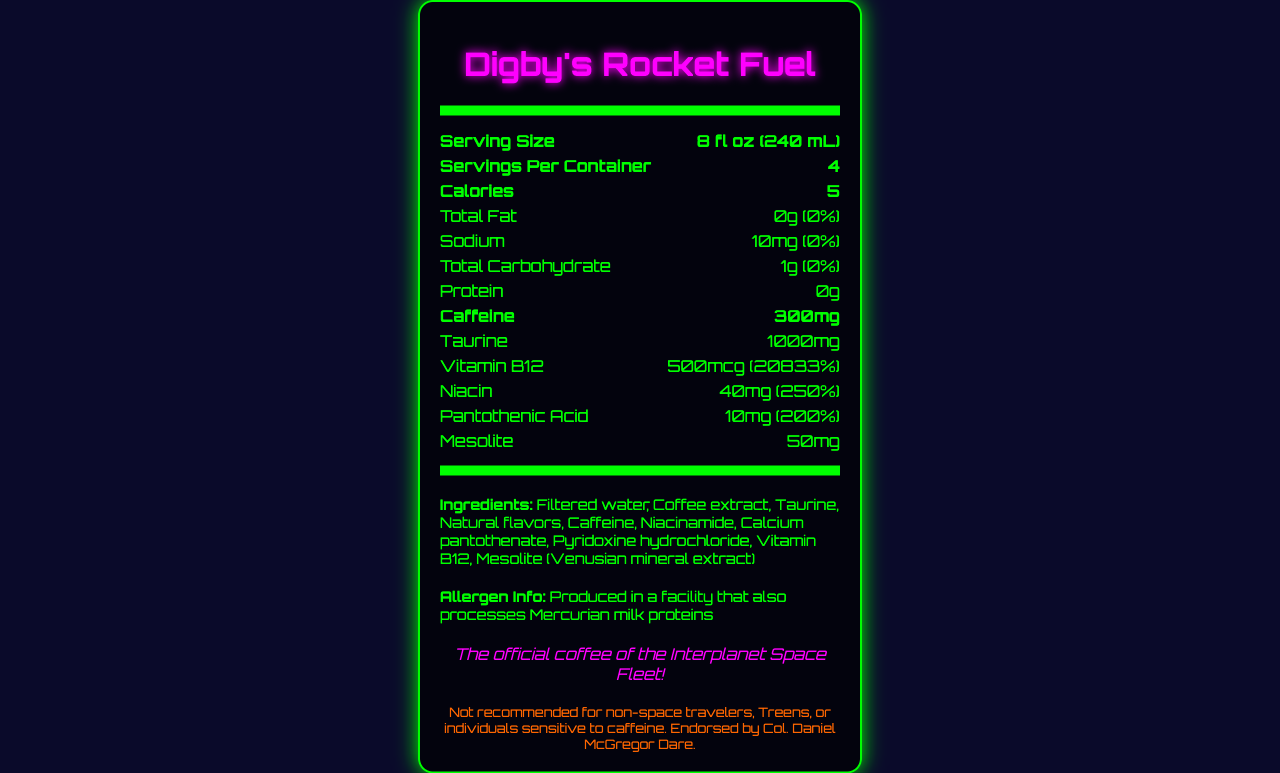what is the serving size? The serving size is listed in the document as 8 fl oz (240 mL).
Answer: 8 fl oz (240 mL) how many calories are in one serving? The document shows that one serving contains 5 calories.
Answer: 5 calories what does the document list as the amount of caffeine per serving? The amount of caffeine per serving is indicated as 300mg in the document.
Answer: 300mg how much Vitamin B12 is there per serving? The document states that each serving contains 500mcg of Vitamin B12, providing 20833% of the daily value.
Answer: 500mcg (20833% Daily Value) who is the manufacturer of Digby's Rocket Fuel? The manufacturer's name listed in the document is Spacefleet Provisions Ltd.
Answer: Spacefleet Provisions Ltd. what total carbohydrate is listed per serving? The document lists total carbohydrate as 1g per serving.
Answer: 1g what is the allergen warning provided in the document? The allergen information in the document states that the product is produced in a facility that also processes Mercurian milk proteins.
Answer: Produced in a facility that also processes Mercurian milk proteins which of the following ingredients is included in Digby's Rocket Fuel? A. Artificial flavors B. Sugar C. Taurine D. Salt The ingredients list includes Taurine but does not mention artificial flavors, sugar, or salt.
Answer: C. Taurine how much taurine is present in each serving? A. 100mg B. 500mg C. 1000mg D. 1500mg The document lists taurine content as 1000mg per serving.
Answer: C. 1000mg what is the tagline for Digby's Rocket Fuel? The tagline given in the document is "The official coffee of the Interplanet Space Fleet!"
Answer: The official coffee of the Interplanet Space Fleet! are there any proteins in this coffee blend? The protein amount per serving is 0g, as shown in the document, indicating no protein content.
Answer: No is this product recommended for Treens or individuals sensitive to caffeine? According to the disclaimer, the product is not recommended for non-space travelers, Treens, or individuals sensitive to caffeine.
Answer: No what can you describe about the entire document? The document lays out detailed nutritional information for Digby's Rocket Fuel, including serving size, key nutrients, caffeine, vitamins, ingredients, allergen info, and product endorsements.
Answer: The document provides the nutrition facts for "Digby's Rocket Fuel" high-caffeine coffee blend. It includes information on serving size, servings per container, calories, key nutrient amounts and their daily values, caffeine level, vitamin content, and other ingredients. It also features a tagline, manufacturer details, an allergen warning, and a disclaimer for sensitive individuals. what is mesolite, as mentioned in the document? The document explains that mesolite is a Venusian mineral extract.
Answer: A Venusian mineral extract what is the impact of consuming multiple servings in one day? The document does not provide specific details on the effects of consuming multiple servings in one day.
Answer: Not enough information 